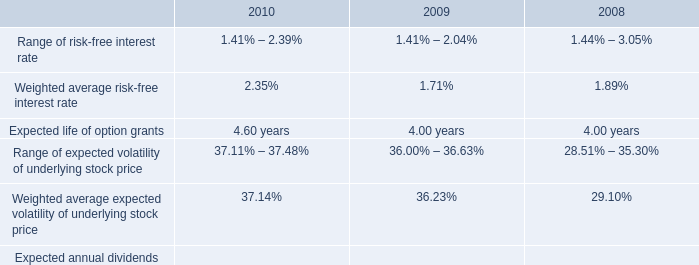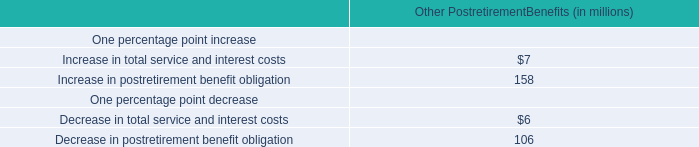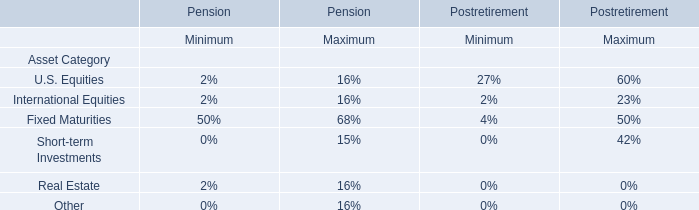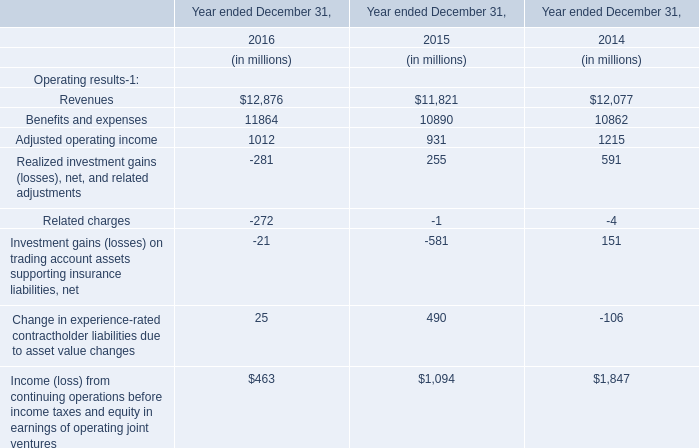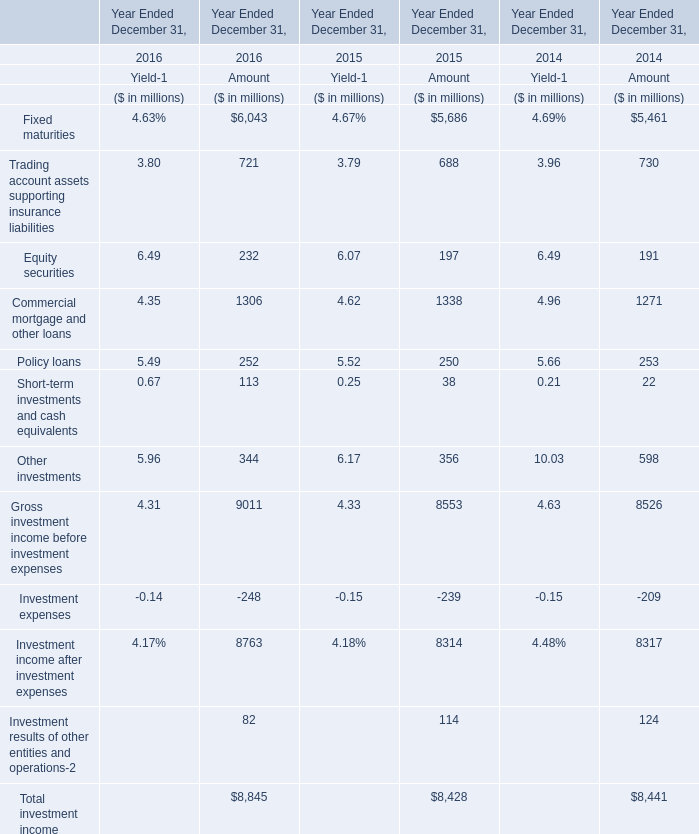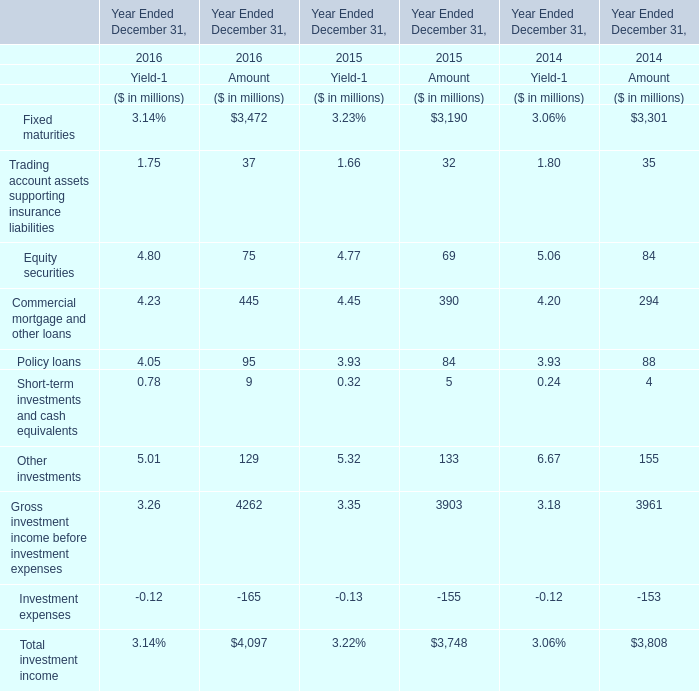What is the average increasing rate of Policy loans for amountbetween 2015 and 2016? 
Computations: ((((95 - 84) / 84) + ((84 - 88) / 88)) / 2)
Answer: 0.04275. 